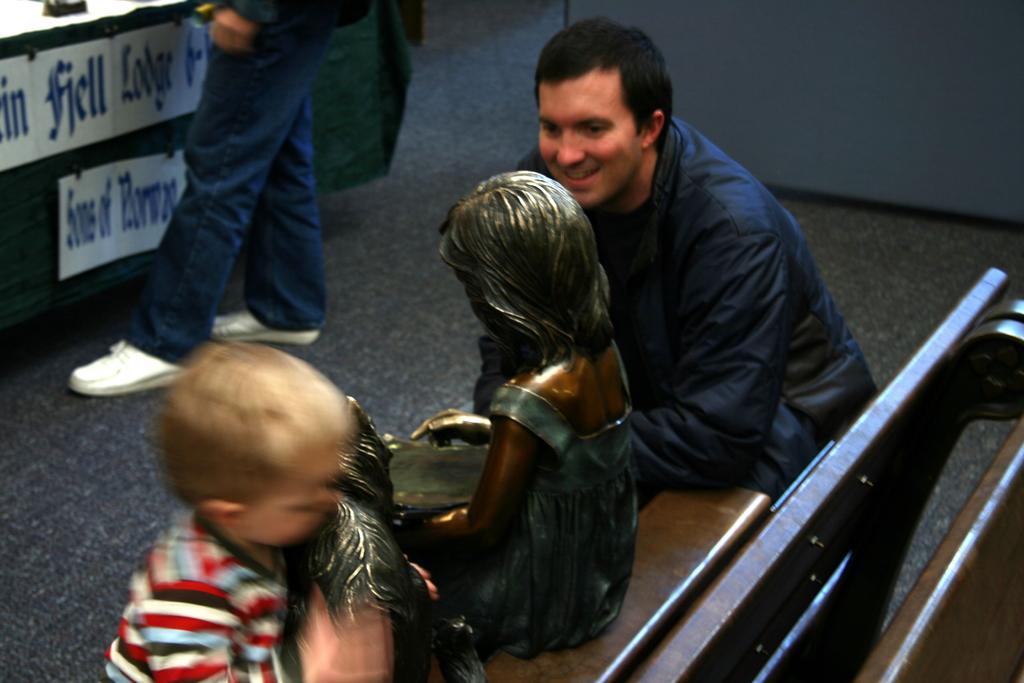Can you describe this image briefly? There are people and we can see sculpture sitting on the bench. We can see wall and floor and we can see boards on green surface. 